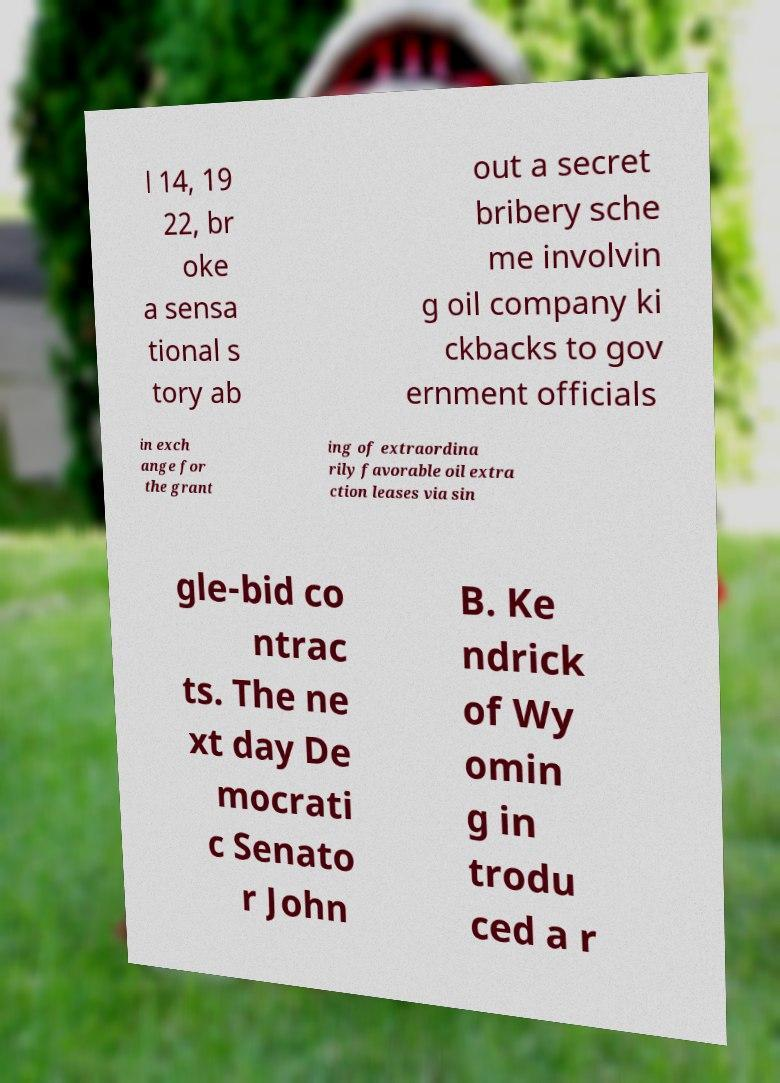Please identify and transcribe the text found in this image. l 14, 19 22, br oke a sensa tional s tory ab out a secret bribery sche me involvin g oil company ki ckbacks to gov ernment officials in exch ange for the grant ing of extraordina rily favorable oil extra ction leases via sin gle-bid co ntrac ts. The ne xt day De mocrati c Senato r John B. Ke ndrick of Wy omin g in trodu ced a r 